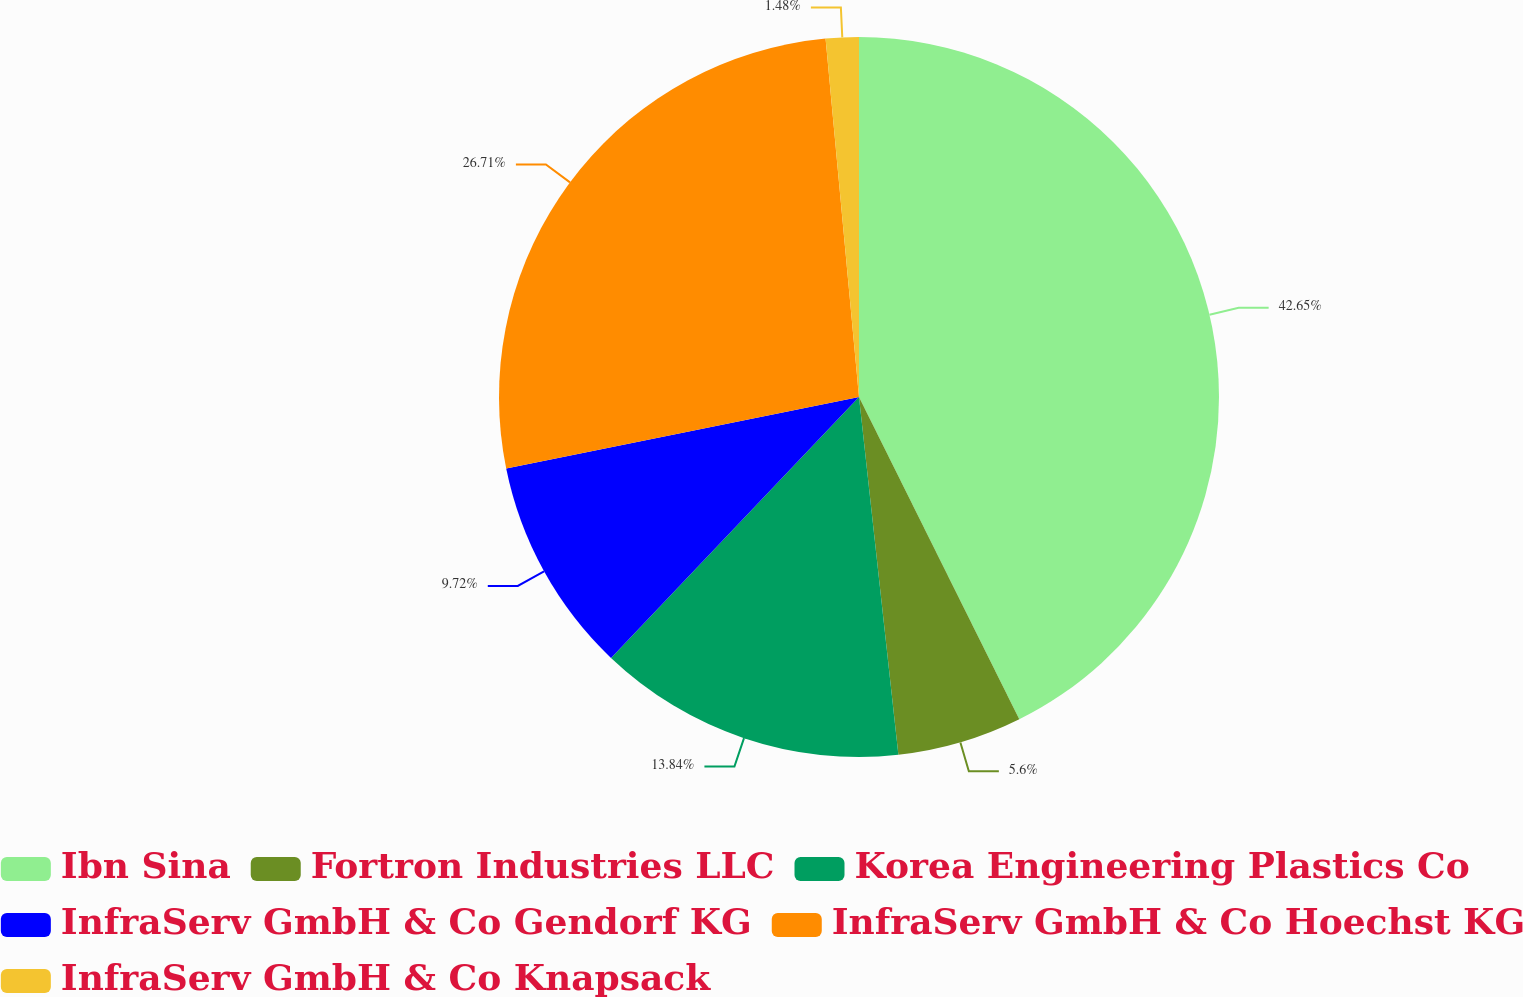<chart> <loc_0><loc_0><loc_500><loc_500><pie_chart><fcel>Ibn Sina<fcel>Fortron Industries LLC<fcel>Korea Engineering Plastics Co<fcel>InfraServ GmbH & Co Gendorf KG<fcel>InfraServ GmbH & Co Hoechst KG<fcel>InfraServ GmbH & Co Knapsack<nl><fcel>42.66%<fcel>5.6%<fcel>13.84%<fcel>9.72%<fcel>26.71%<fcel>1.48%<nl></chart> 